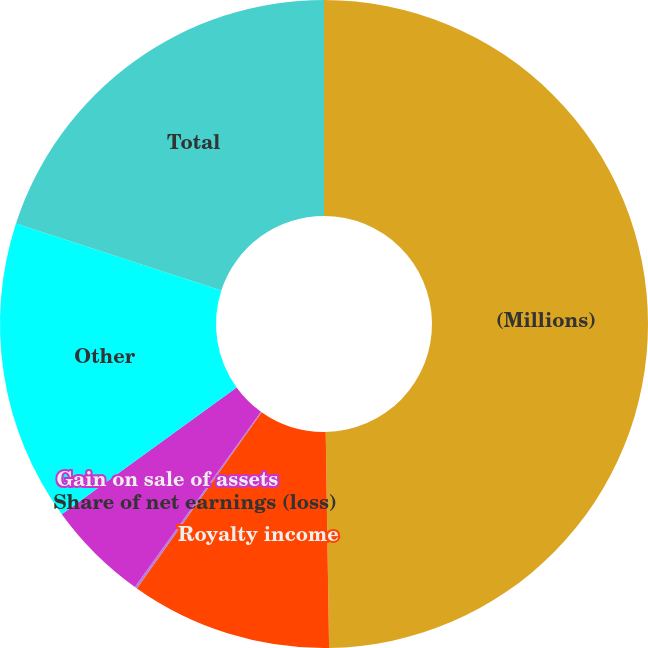Convert chart to OTSL. <chart><loc_0><loc_0><loc_500><loc_500><pie_chart><fcel>(Millions)<fcel>Royalty income<fcel>Share of net earnings (loss)<fcel>Gain on sale of assets<fcel>Other<fcel>Total<nl><fcel>49.75%<fcel>10.05%<fcel>0.12%<fcel>5.09%<fcel>15.01%<fcel>19.98%<nl></chart> 